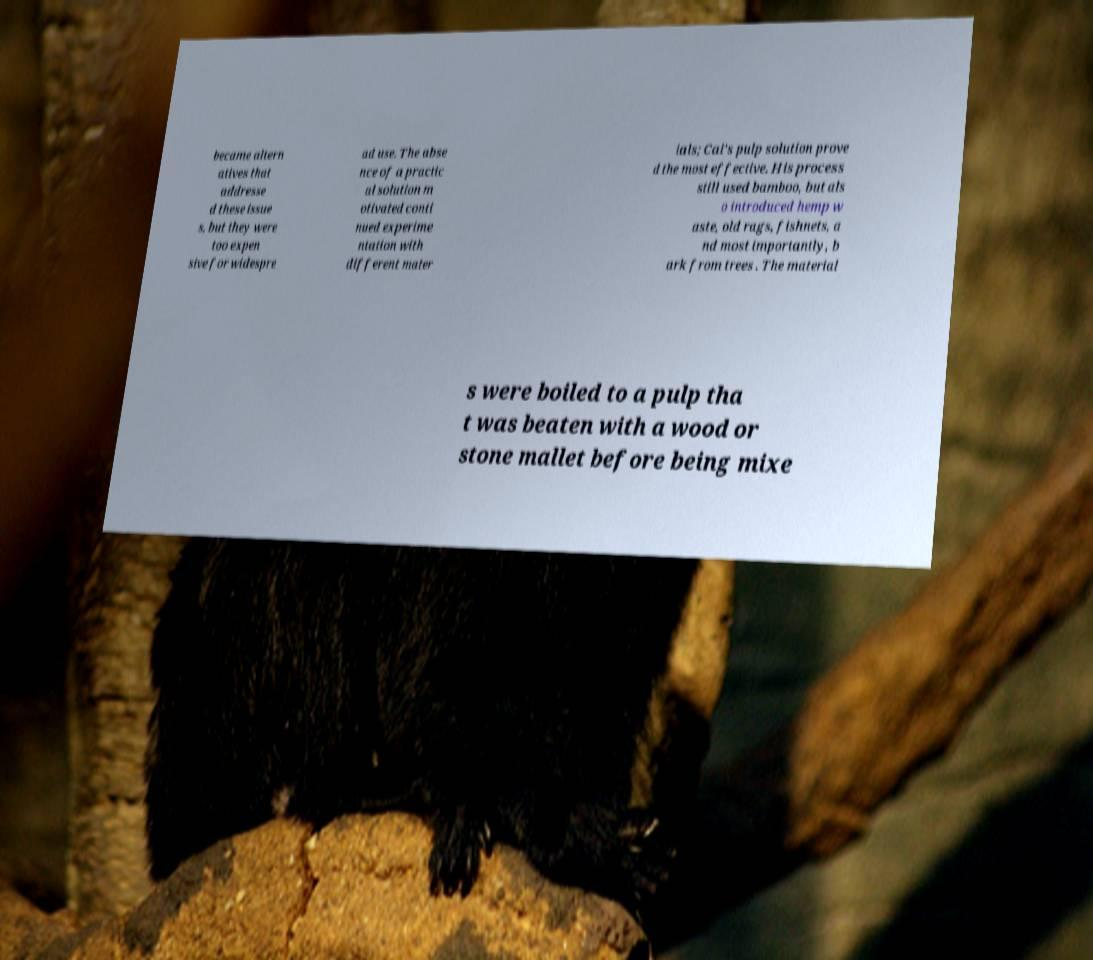Please identify and transcribe the text found in this image. became altern atives that addresse d these issue s, but they were too expen sive for widespre ad use. The abse nce of a practic al solution m otivated conti nued experime ntation with different mater ials; Cai's pulp solution prove d the most effective. His process still used bamboo, but als o introduced hemp w aste, old rags, fishnets, a nd most importantly, b ark from trees . The material s were boiled to a pulp tha t was beaten with a wood or stone mallet before being mixe 